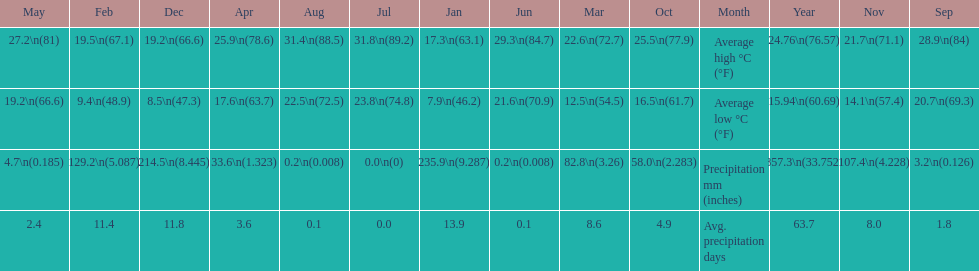What is the month with the lowest average low in haifa? January. 